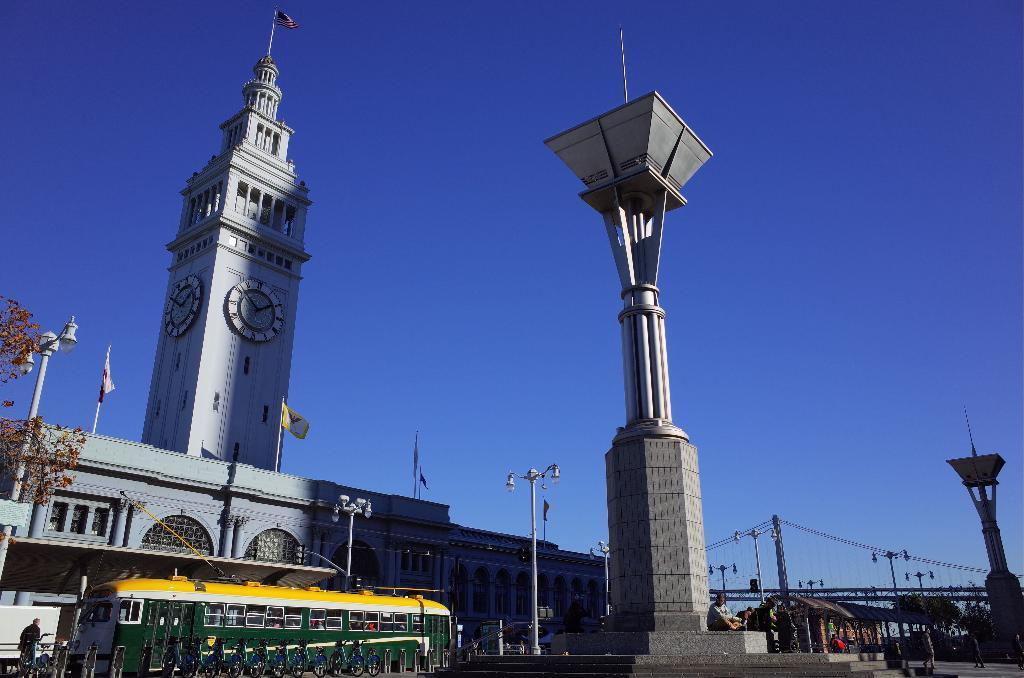Describe this image in one or two sentences. In this image, we can see towers. There is a bus and some poles in front of the building. There is a bridge in the bottom right of the image. There are bicycles in the bottom left of the image. There are flags on the building. In the background of the image, there is a sky. 